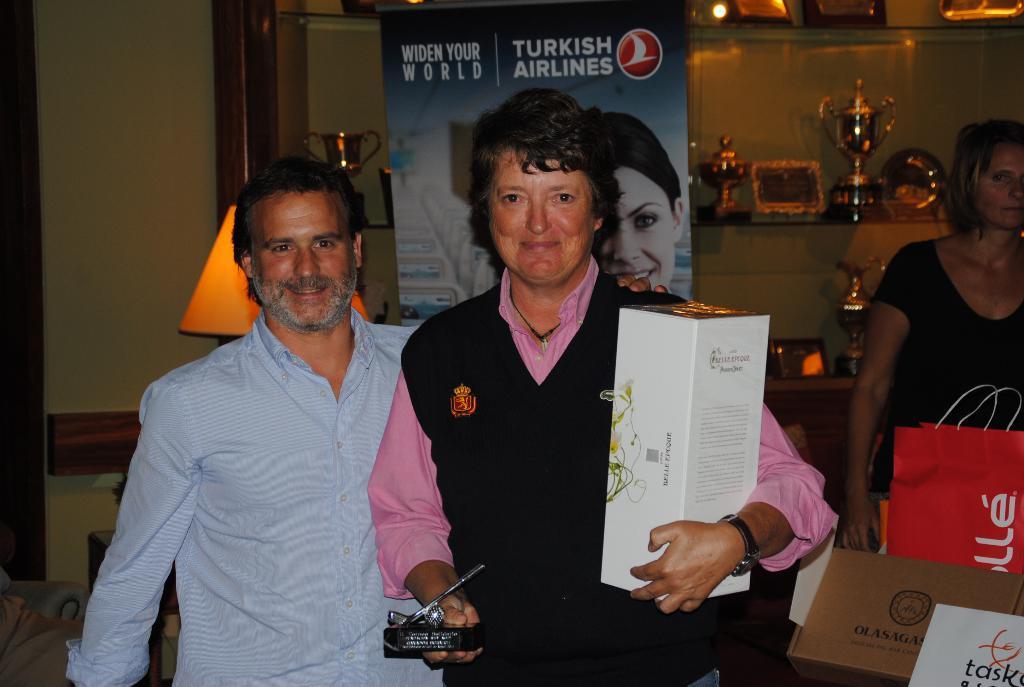Could you give a brief overview of what you see in this image? In the image we can see there are three people standing, they are wearing clothes. This person is wearing a wrist watch and a neck chain, and the person is holding a box in hand. This is a paper bag, poster, trophies and shelves. The two of them are smiling. 